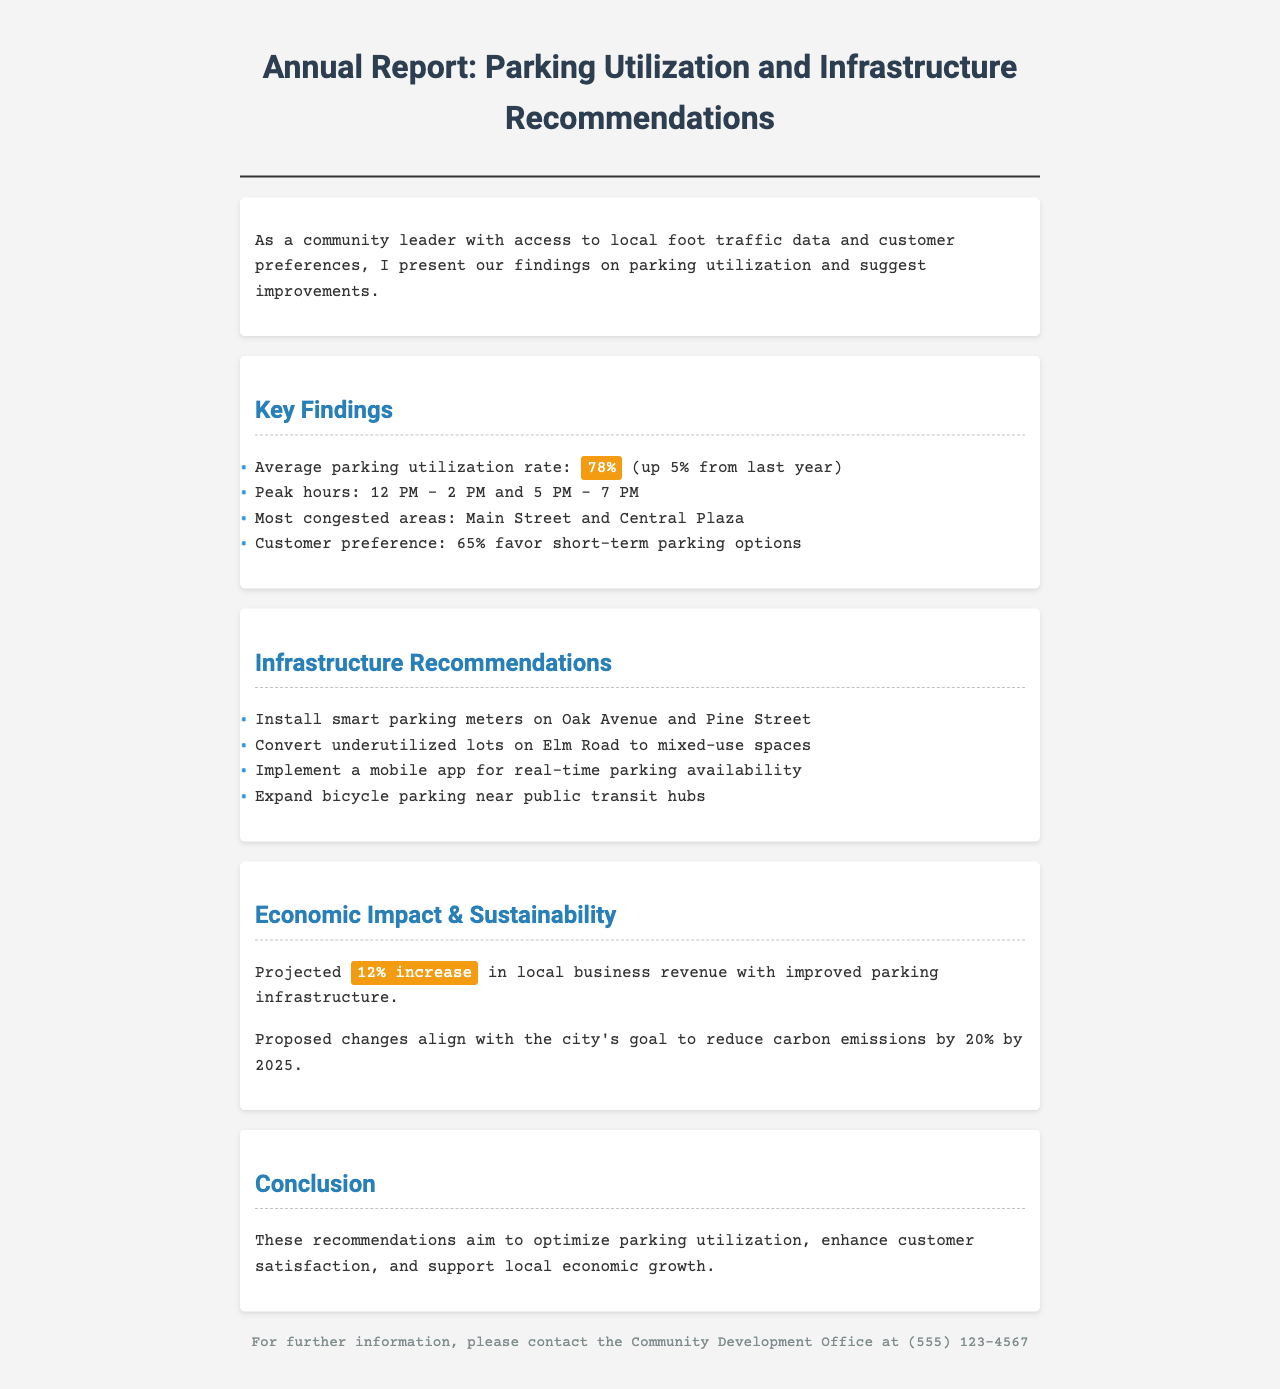what is the average parking utilization rate? The average parking utilization rate is mentioned in the document as being 78%.
Answer: 78% what percentage of customers favor short-term parking options? The document states that 65% of customers favor short-term parking options.
Answer: 65% what are the peak hours for parking utilization? The document identifies the peak hours as 12 PM - 2 PM and 5 PM - 7 PM.
Answer: 12 PM - 2 PM and 5 PM - 7 PM what is the projected increase in local business revenue with improved infrastructure? The document projects a 12% increase in local business revenue.
Answer: 12% which streets are recommended for installing smart parking meters? The document recommends installing smart parking meters on Oak Avenue and Pine Street.
Answer: Oak Avenue and Pine Street what is the main congestion area mentioned in the report? The most congested areas highlighted in the document are Main Street and Central Plaza.
Answer: Main Street and Central Plaza what is the city's goal regarding carbon emissions by 2025? The document states the city's goal is to reduce carbon emissions by 20% by 2025.
Answer: 20% what does the conclusion aim to achieve? The conclusion mentions that the recommendations aim to optimize parking utilization, enhance customer satisfaction, and support local economic growth.
Answer: Optimize parking utilization, enhance customer satisfaction, and support local economic growth 